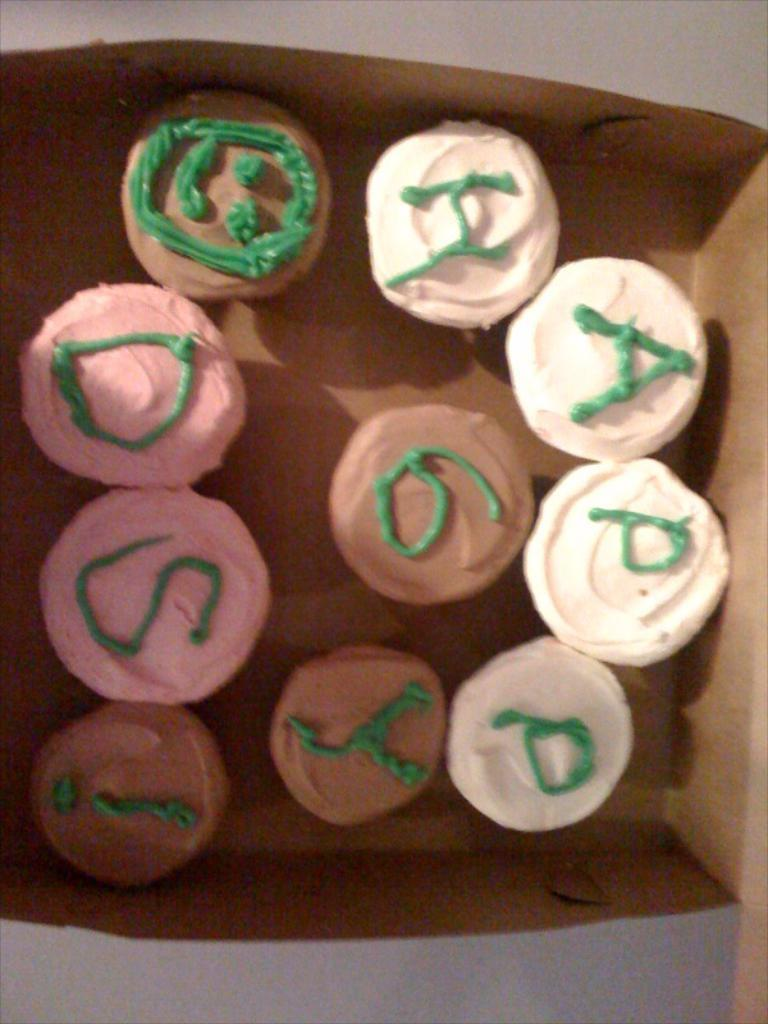What type of food is visible in the image? There are cupcakes in the image. How are the cupcakes packaged or contained? The cupcakes are in a brown color box. What colors can be seen on the cupcakes? The cupcakes have white, brown, and pink colors. What type of animal can be seen breathing near the gate in the image? There is no animal or gate present in the image; it only features cupcakes in a brown color box. 